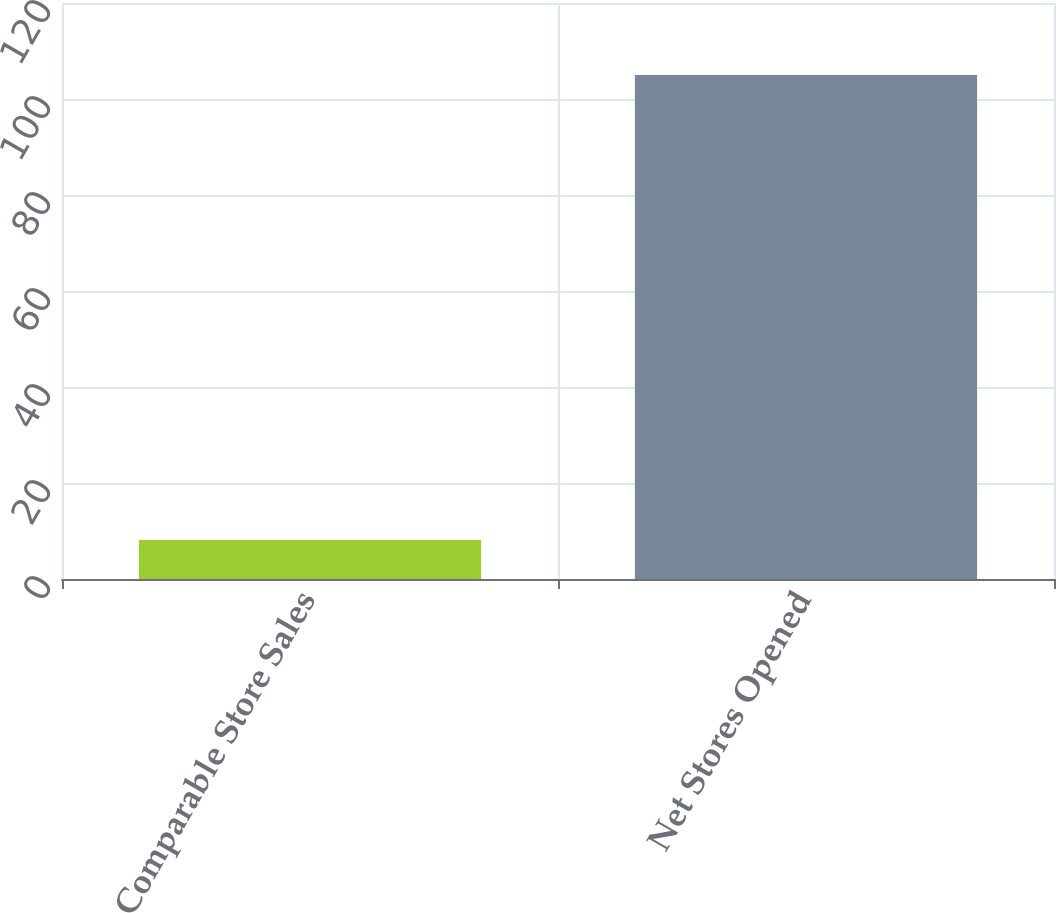Convert chart. <chart><loc_0><loc_0><loc_500><loc_500><bar_chart><fcel>Comparable Store Sales<fcel>Net Stores Opened<nl><fcel>8.1<fcel>105<nl></chart> 